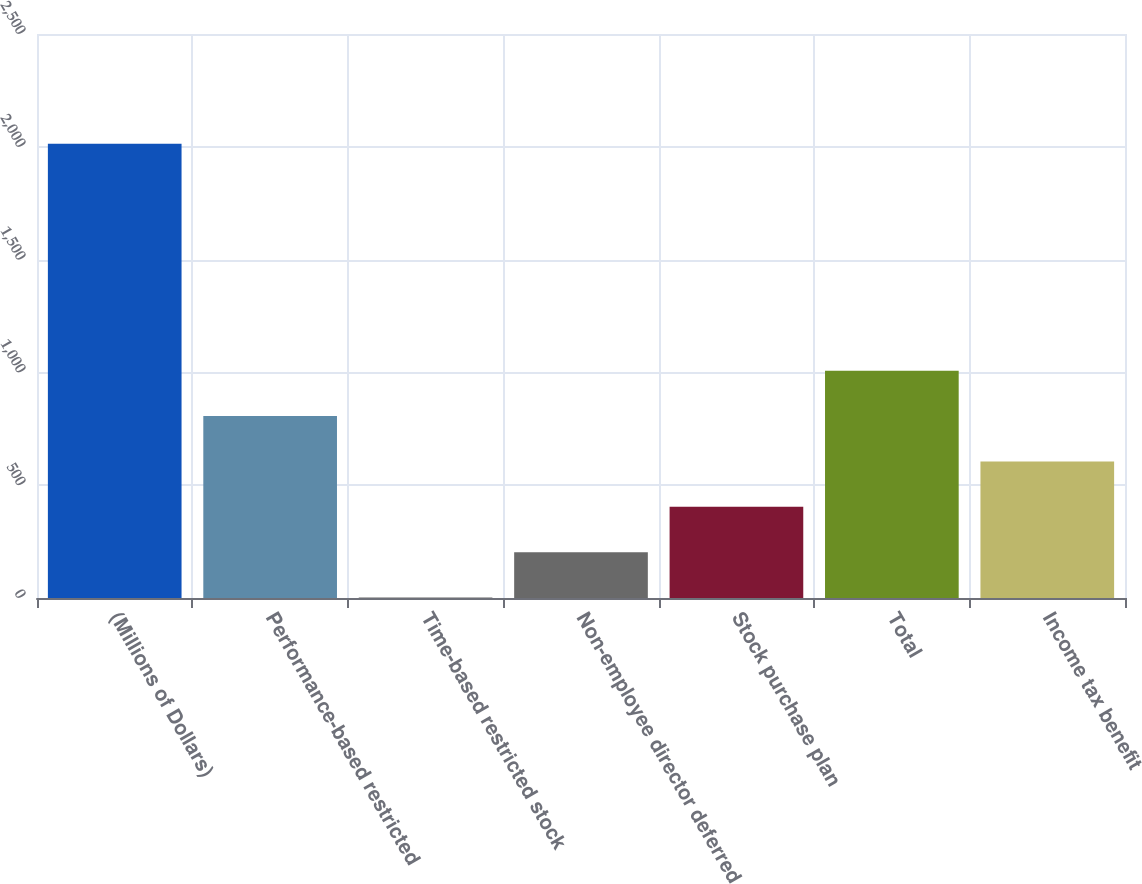<chart> <loc_0><loc_0><loc_500><loc_500><bar_chart><fcel>(Millions of Dollars)<fcel>Performance-based restricted<fcel>Time-based restricted stock<fcel>Non-employee director deferred<fcel>Stock purchase plan<fcel>Total<fcel>Income tax benefit<nl><fcel>2013<fcel>806.4<fcel>2<fcel>203.1<fcel>404.2<fcel>1007.5<fcel>605.3<nl></chart> 